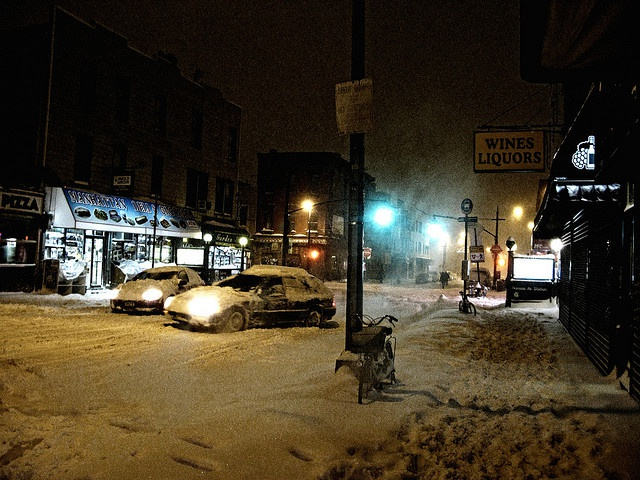Describe the objects in this image and their specific colors. I can see car in black, olive, ivory, and maroon tones, bicycle in black, darkgreen, and gray tones, car in black, tan, white, and olive tones, traffic light in black, white, cyan, and lightblue tones, and traffic light in black, white, lightblue, and teal tones in this image. 